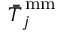<formula> <loc_0><loc_0><loc_500><loc_500>\bar { \bar { T } } _ { j } ^ { \, m m }</formula> 